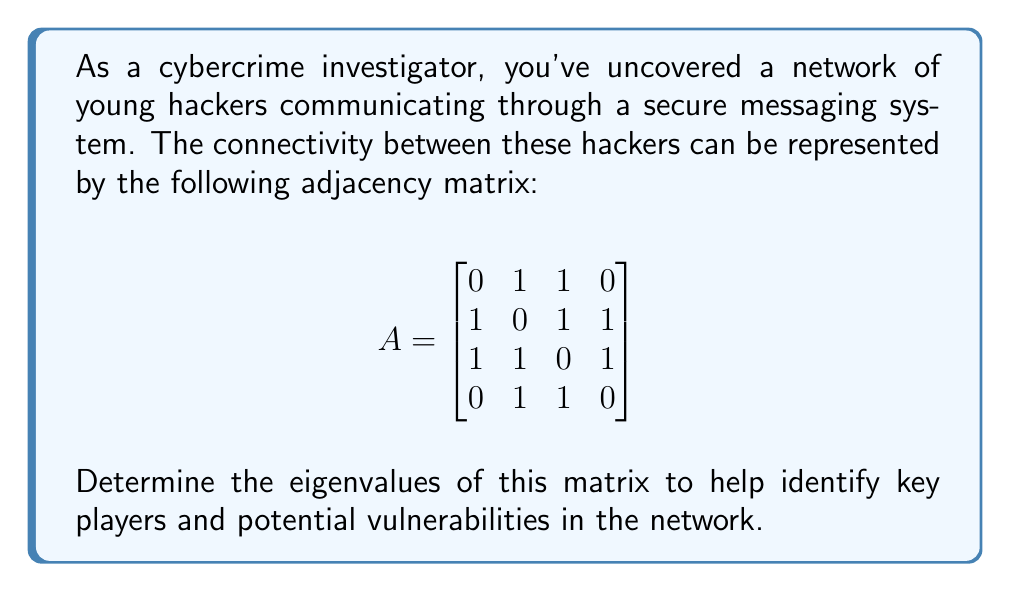Solve this math problem. To find the eigenvalues of matrix $A$, we need to solve the characteristic equation:

1) First, we set up the equation $\det(A - \lambda I) = 0$, where $I$ is the 4x4 identity matrix:

   $$\det\begin{pmatrix}
   -\lambda & 1 & 1 & 0 \\
   1 & -\lambda & 1 & 1 \\
   1 & 1 & -\lambda & 1 \\
   0 & 1 & 1 & -\lambda
   \end{pmatrix} = 0$$

2) Expanding this determinant (using cofactor expansion along the first row):

   $(-\lambda)((-\lambda)^3 - 2\lambda - 2) - 1(-\lambda^2 - 1 + \lambda) + 1(-\lambda^2 - 1 + \lambda) - 0 = 0$

3) Simplifying:

   $\lambda^4 - 3\lambda^2 - 2\lambda - 1 = 0$

4) This is our characteristic polynomial. To solve it, we can use the rational root theorem or factor it:

   $(\lambda^2 + 1)(\lambda^2 - 3\lambda - 1) = 0$

5) Solving each factor:

   $\lambda^2 + 1 = 0$ gives $\lambda = \pm i$
   
   $\lambda^2 - 3\lambda - 1 = 0$ gives $\lambda = \frac{3 \pm \sqrt{13}}{2}$

Therefore, the eigenvalues are $\frac{3 + \sqrt{13}}{2}$, $\frac{3 - \sqrt{13}}{2}$, $i$, and $-i$.
Answer: $\frac{3 + \sqrt{13}}{2}$, $\frac{3 - \sqrt{13}}{2}$, $i$, $-i$ 